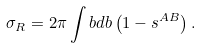<formula> <loc_0><loc_0><loc_500><loc_500>\sigma _ { R } = 2 \pi \int b d b \left ( 1 - s ^ { A B } \right ) .</formula> 